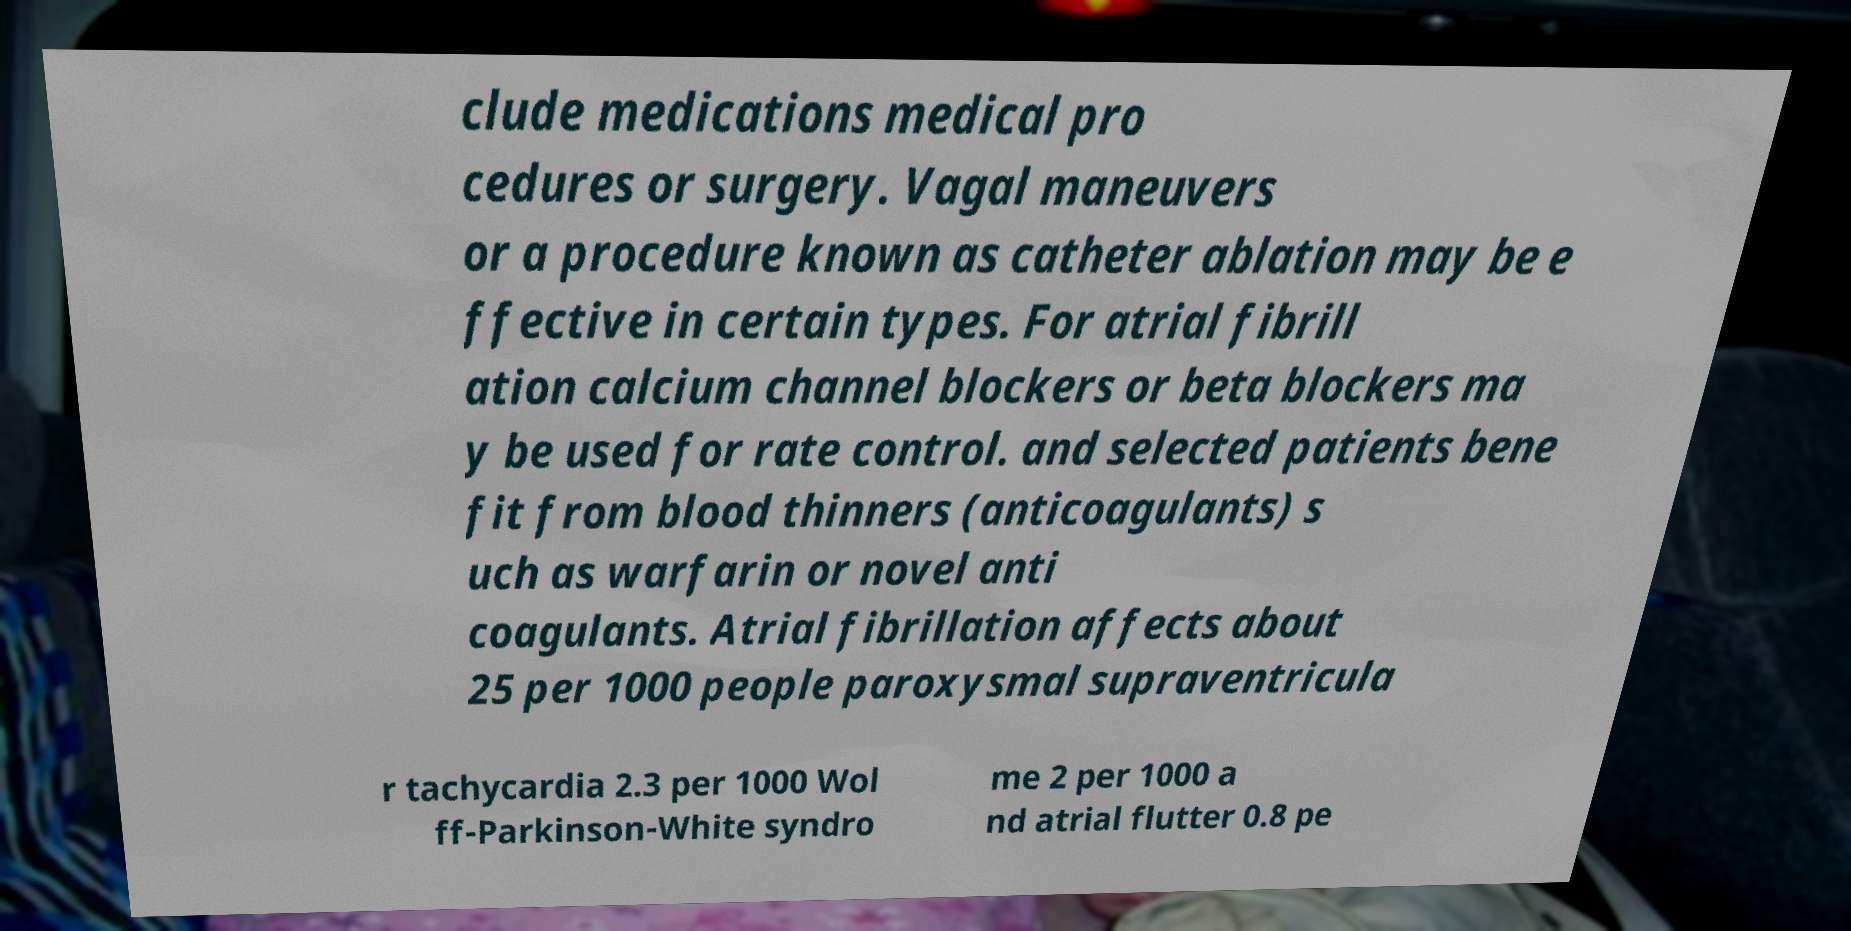Please identify and transcribe the text found in this image. clude medications medical pro cedures or surgery. Vagal maneuvers or a procedure known as catheter ablation may be e ffective in certain types. For atrial fibrill ation calcium channel blockers or beta blockers ma y be used for rate control. and selected patients bene fit from blood thinners (anticoagulants) s uch as warfarin or novel anti coagulants. Atrial fibrillation affects about 25 per 1000 people paroxysmal supraventricula r tachycardia 2.3 per 1000 Wol ff-Parkinson-White syndro me 2 per 1000 a nd atrial flutter 0.8 pe 